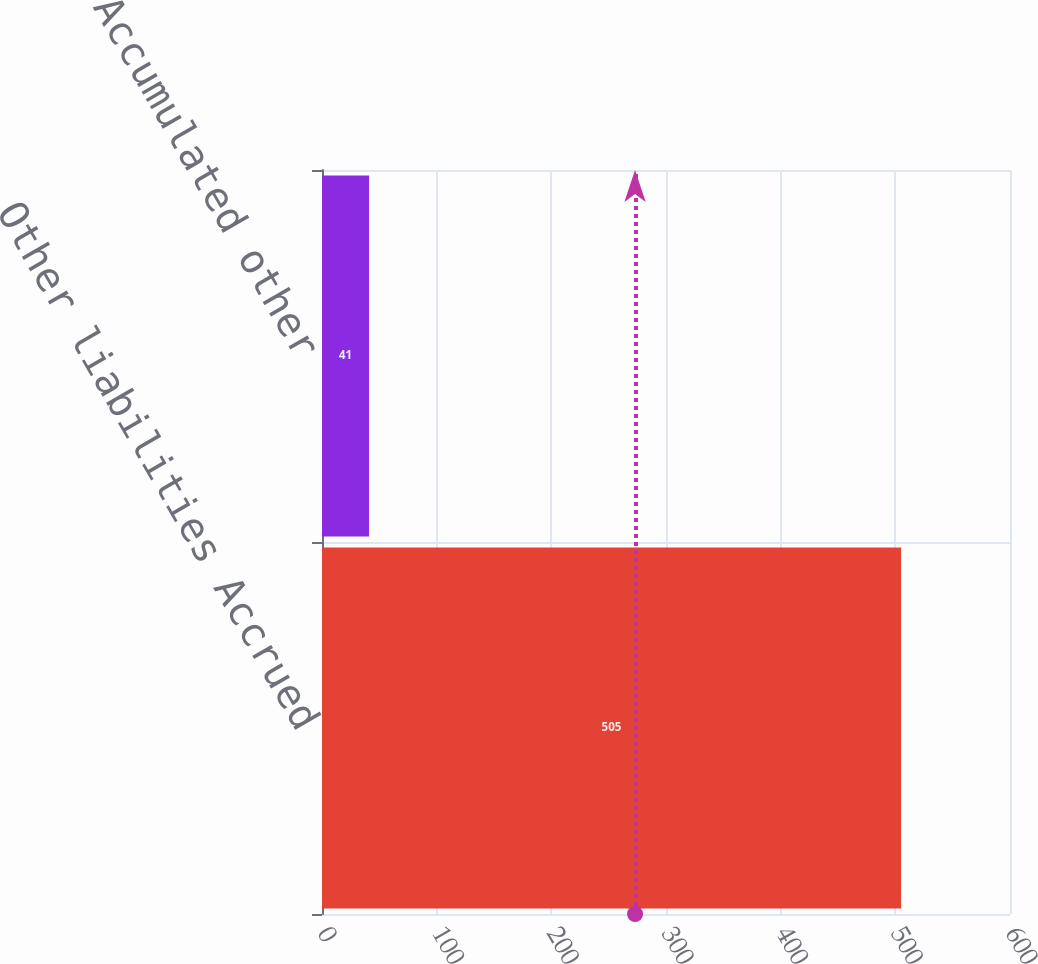<chart> <loc_0><loc_0><loc_500><loc_500><bar_chart><fcel>Other liabilities Accrued<fcel>Accumulated other<nl><fcel>505<fcel>41<nl></chart> 